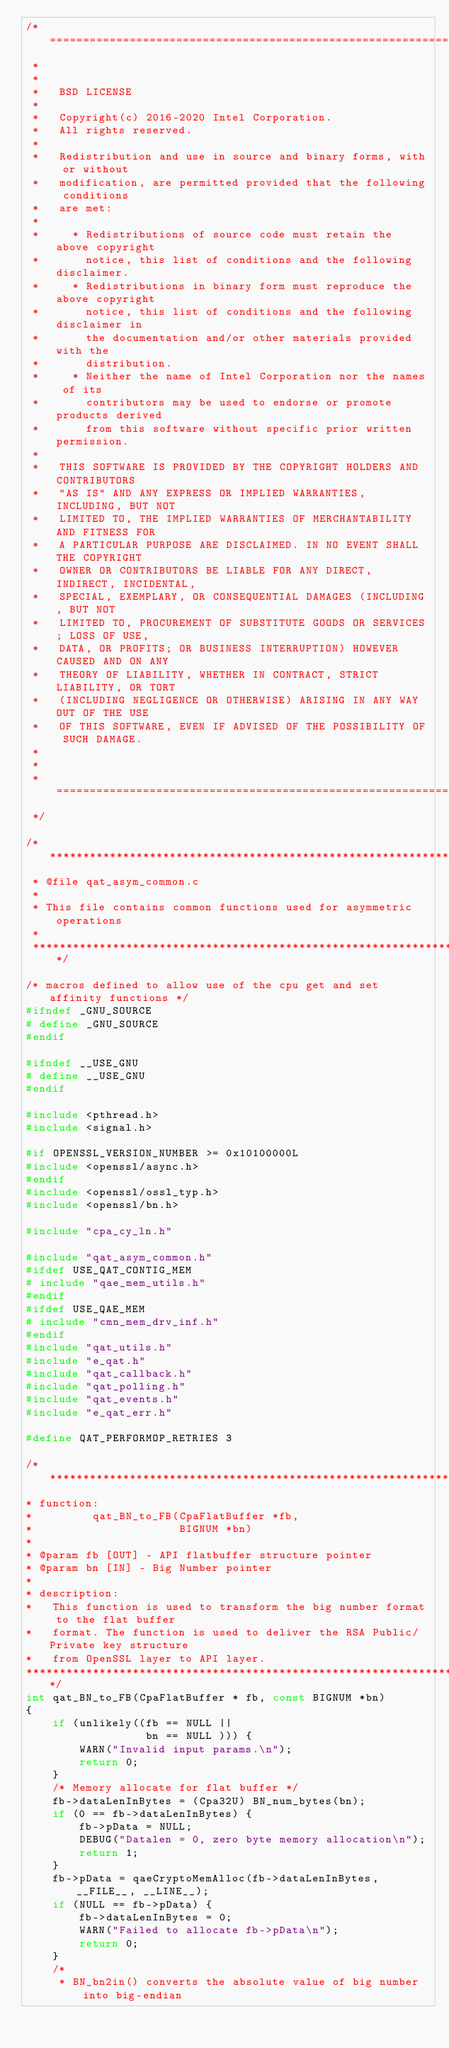Convert code to text. <code><loc_0><loc_0><loc_500><loc_500><_C_>/* ====================================================================
 *
 *
 *   BSD LICENSE
 *
 *   Copyright(c) 2016-2020 Intel Corporation.
 *   All rights reserved.
 *
 *   Redistribution and use in source and binary forms, with or without
 *   modification, are permitted provided that the following conditions
 *   are met:
 *
 *     * Redistributions of source code must retain the above copyright
 *       notice, this list of conditions and the following disclaimer.
 *     * Redistributions in binary form must reproduce the above copyright
 *       notice, this list of conditions and the following disclaimer in
 *       the documentation and/or other materials provided with the
 *       distribution.
 *     * Neither the name of Intel Corporation nor the names of its
 *       contributors may be used to endorse or promote products derived
 *       from this software without specific prior written permission.
 *
 *   THIS SOFTWARE IS PROVIDED BY THE COPYRIGHT HOLDERS AND CONTRIBUTORS
 *   "AS IS" AND ANY EXPRESS OR IMPLIED WARRANTIES, INCLUDING, BUT NOT
 *   LIMITED TO, THE IMPLIED WARRANTIES OF MERCHANTABILITY AND FITNESS FOR
 *   A PARTICULAR PURPOSE ARE DISCLAIMED. IN NO EVENT SHALL THE COPYRIGHT
 *   OWNER OR CONTRIBUTORS BE LIABLE FOR ANY DIRECT, INDIRECT, INCIDENTAL,
 *   SPECIAL, EXEMPLARY, OR CONSEQUENTIAL DAMAGES (INCLUDING, BUT NOT
 *   LIMITED TO, PROCUREMENT OF SUBSTITUTE GOODS OR SERVICES; LOSS OF USE,
 *   DATA, OR PROFITS; OR BUSINESS INTERRUPTION) HOWEVER CAUSED AND ON ANY
 *   THEORY OF LIABILITY, WHETHER IN CONTRACT, STRICT LIABILITY, OR TORT
 *   (INCLUDING NEGLIGENCE OR OTHERWISE) ARISING IN ANY WAY OUT OF THE USE
 *   OF THIS SOFTWARE, EVEN IF ADVISED OF THE POSSIBILITY OF SUCH DAMAGE.
 *
 *
 * ====================================================================
 */

/*****************************************************************************
 * @file qat_asym_common.c
 *
 * This file contains common functions used for asymmetric operations
 *
 *****************************************************************************/

/* macros defined to allow use of the cpu get and set affinity functions */
#ifndef _GNU_SOURCE
# define _GNU_SOURCE
#endif

#ifndef __USE_GNU
# define __USE_GNU
#endif

#include <pthread.h>
#include <signal.h>

#if OPENSSL_VERSION_NUMBER >= 0x10100000L
#include <openssl/async.h>
#endif
#include <openssl/ossl_typ.h>
#include <openssl/bn.h>

#include "cpa_cy_ln.h"

#include "qat_asym_common.h"
#ifdef USE_QAT_CONTIG_MEM
# include "qae_mem_utils.h"
#endif
#ifdef USE_QAE_MEM
# include "cmn_mem_drv_inf.h"
#endif
#include "qat_utils.h"
#include "e_qat.h"
#include "qat_callback.h"
#include "qat_polling.h"
#include "qat_events.h"
#include "e_qat_err.h"

#define QAT_PERFORMOP_RETRIES 3

/******************************************************************************
* function:
*         qat_BN_to_FB(CpaFlatBuffer *fb,
*                      BIGNUM *bn)
*
* @param fb [OUT] - API flatbuffer structure pointer
* @param bn [IN] - Big Number pointer
*
* description:
*   This function is used to transform the big number format to the flat buffer
*   format. The function is used to deliver the RSA Public/Private key structure
*   from OpenSSL layer to API layer.
******************************************************************************/
int qat_BN_to_FB(CpaFlatBuffer * fb, const BIGNUM *bn)
{
    if (unlikely((fb == NULL ||
                  bn == NULL ))) {
        WARN("Invalid input params.\n");
        return 0;
    }
    /* Memory allocate for flat buffer */
    fb->dataLenInBytes = (Cpa32U) BN_num_bytes(bn);
    if (0 == fb->dataLenInBytes) {
        fb->pData = NULL;
        DEBUG("Datalen = 0, zero byte memory allocation\n");
        return 1;
    }
    fb->pData = qaeCryptoMemAlloc(fb->dataLenInBytes, __FILE__, __LINE__);
    if (NULL == fb->pData) {
        fb->dataLenInBytes = 0;
        WARN("Failed to allocate fb->pData\n");
        return 0;
    }
    /*
     * BN_bn2in() converts the absolute value of big number into big-endian</code> 